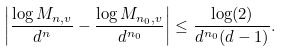<formula> <loc_0><loc_0><loc_500><loc_500>\left | \frac { \log M _ { n , v } } { d ^ { n } } - \frac { \log M _ { n _ { 0 } , v } } { d ^ { n _ { 0 } } } \right | \leq \frac { \log ( 2 ) } { d ^ { n _ { 0 } } ( d - 1 ) } .</formula> 